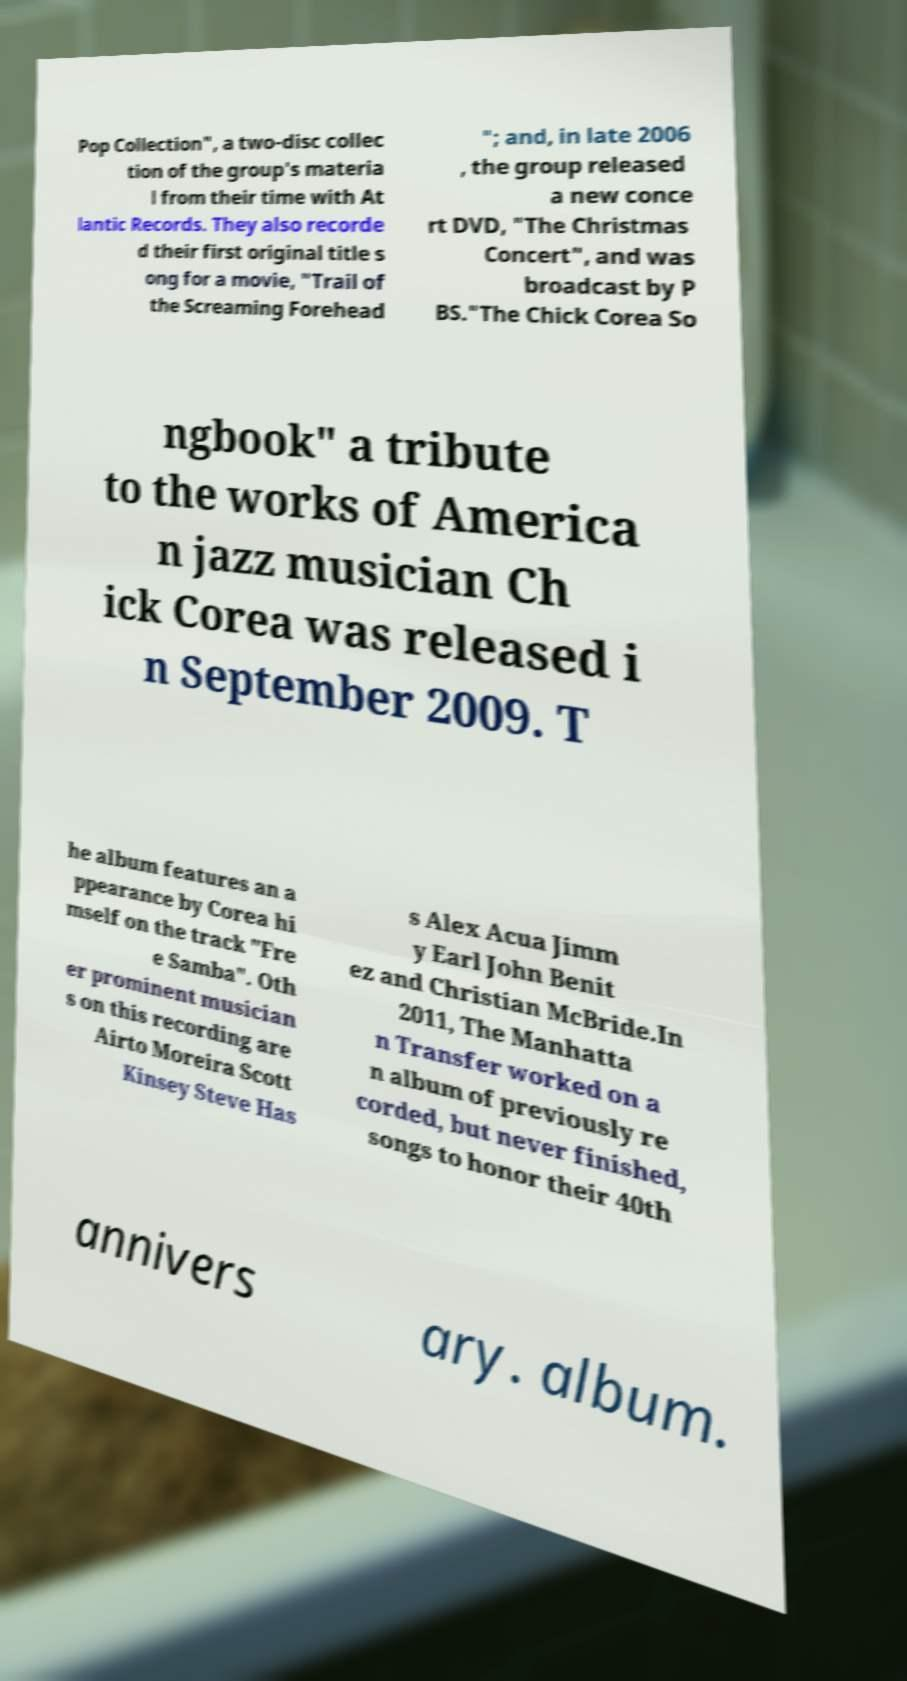Could you assist in decoding the text presented in this image and type it out clearly? Pop Collection", a two-disc collec tion of the group's materia l from their time with At lantic Records. They also recorde d their first original title s ong for a movie, "Trail of the Screaming Forehead "; and, in late 2006 , the group released a new conce rt DVD, "The Christmas Concert", and was broadcast by P BS."The Chick Corea So ngbook" a tribute to the works of America n jazz musician Ch ick Corea was released i n September 2009. T he album features an a ppearance by Corea hi mself on the track "Fre e Samba". Oth er prominent musician s on this recording are Airto Moreira Scott Kinsey Steve Has s Alex Acua Jimm y Earl John Benit ez and Christian McBride.In 2011, The Manhatta n Transfer worked on a n album of previously re corded, but never finished, songs to honor their 40th annivers ary. album. 